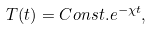Convert formula to latex. <formula><loc_0><loc_0><loc_500><loc_500>T ( t ) = C o n s t . e ^ { - \chi t } ,</formula> 